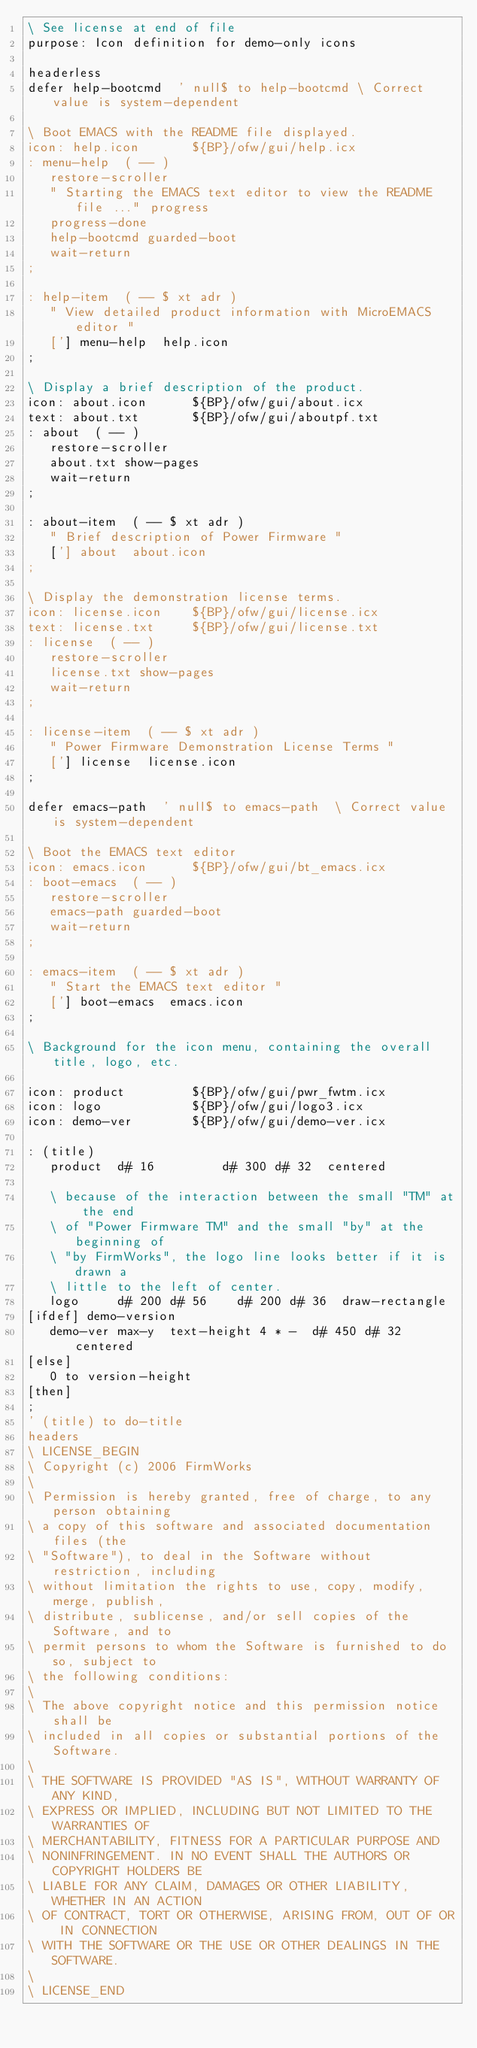<code> <loc_0><loc_0><loc_500><loc_500><_Forth_>\ See license at end of file
purpose: Icon definition for demo-only icons

headerless
defer help-bootcmd  ' null$ to help-bootcmd \ Correct value is system-dependent

\ Boot EMACS with the README file displayed.
icon: help.icon       ${BP}/ofw/gui/help.icx
: menu-help  ( -- )
   restore-scroller
   " Starting the EMACS text editor to view the README file ..." progress
   progress-done
   help-bootcmd guarded-boot
   wait-return
;

: help-item  ( -- $ xt adr )
   " View detailed product information with MicroEMACS editor "
   ['] menu-help  help.icon
;

\ Display a brief description of the product.
icon: about.icon      ${BP}/ofw/gui/about.icx
text: about.txt       ${BP}/ofw/gui/aboutpf.txt
: about  ( -- )
   restore-scroller
   about.txt show-pages
   wait-return
;

: about-item  ( -- $ xt adr )
   " Brief description of Power Firmware "
   ['] about  about.icon
;

\ Display the demonstration license terms.
icon: license.icon    ${BP}/ofw/gui/license.icx
text: license.txt     ${BP}/ofw/gui/license.txt
: license  ( -- )
   restore-scroller
   license.txt show-pages
   wait-return
;

: license-item  ( -- $ xt adr )
   " Power Firmware Demonstration License Terms "
   ['] license  license.icon
;

defer emacs-path  ' null$ to emacs-path  \ Correct value is system-dependent

\ Boot the EMACS text editor
icon: emacs.icon      ${BP}/ofw/gui/bt_emacs.icx
: boot-emacs  ( -- )
   restore-scroller
   emacs-path guarded-boot
   wait-return
;

: emacs-item  ( -- $ xt adr )
   " Start the EMACS text editor "
   ['] boot-emacs  emacs.icon
;

\ Background for the icon menu, containing the overall title, logo, etc.

icon: product         ${BP}/ofw/gui/pwr_fwtm.icx
icon: logo            ${BP}/ofw/gui/logo3.icx
icon: demo-ver        ${BP}/ofw/gui/demo-ver.icx

: (title)
   product  d# 16         d# 300 d# 32  centered

   \ because of the interaction between the small "TM" at the end
   \ of "Power Firmware TM" and the small "by" at the beginning of
   \ "by FirmWorks", the logo line looks better if it is drawn a
   \ little to the left of center.
   logo     d# 200 d# 56    d# 200 d# 36  draw-rectangle
[ifdef] demo-version
   demo-ver max-y  text-height 4 * -  d# 450 d# 32  centered
[else]
   0 to version-height
[then]
;
' (title) to do-title
headers
\ LICENSE_BEGIN
\ Copyright (c) 2006 FirmWorks
\ 
\ Permission is hereby granted, free of charge, to any person obtaining
\ a copy of this software and associated documentation files (the
\ "Software"), to deal in the Software without restriction, including
\ without limitation the rights to use, copy, modify, merge, publish,
\ distribute, sublicense, and/or sell copies of the Software, and to
\ permit persons to whom the Software is furnished to do so, subject to
\ the following conditions:
\ 
\ The above copyright notice and this permission notice shall be
\ included in all copies or substantial portions of the Software.
\ 
\ THE SOFTWARE IS PROVIDED "AS IS", WITHOUT WARRANTY OF ANY KIND,
\ EXPRESS OR IMPLIED, INCLUDING BUT NOT LIMITED TO THE WARRANTIES OF
\ MERCHANTABILITY, FITNESS FOR A PARTICULAR PURPOSE AND
\ NONINFRINGEMENT. IN NO EVENT SHALL THE AUTHORS OR COPYRIGHT HOLDERS BE
\ LIABLE FOR ANY CLAIM, DAMAGES OR OTHER LIABILITY, WHETHER IN AN ACTION
\ OF CONTRACT, TORT OR OTHERWISE, ARISING FROM, OUT OF OR IN CONNECTION
\ WITH THE SOFTWARE OR THE USE OR OTHER DEALINGS IN THE SOFTWARE.
\
\ LICENSE_END
</code> 